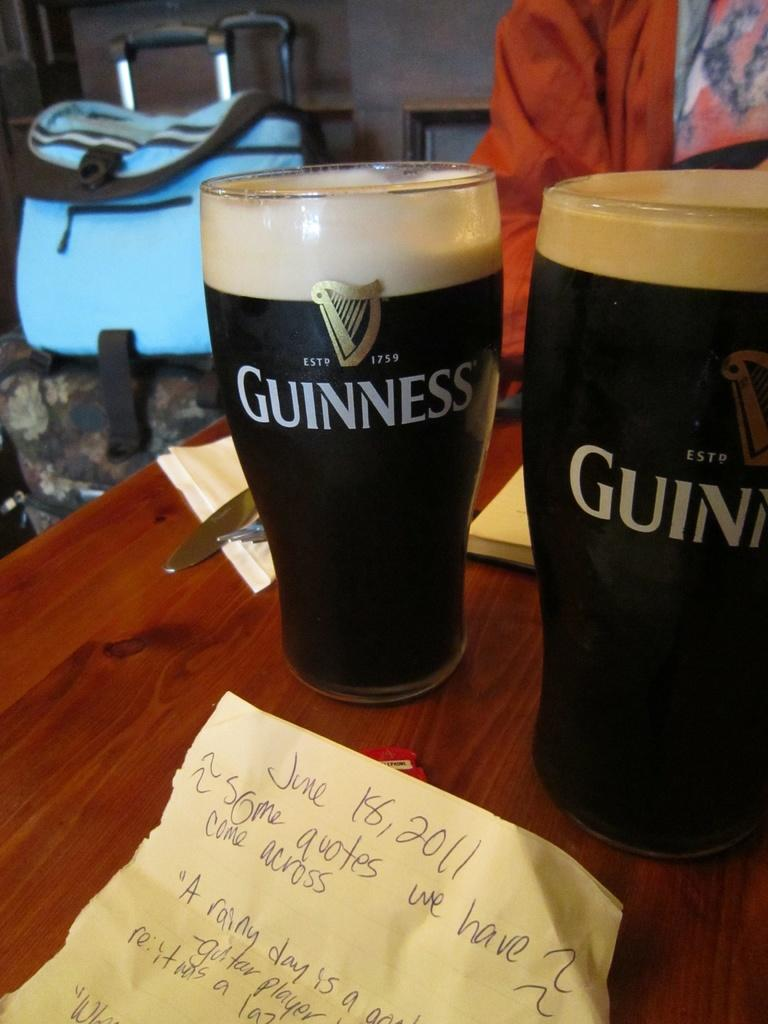How many glasses can be seen in the image? There are two glasses in the image. What else is present in the image besides the glasses? There are papers and other objects on a wooden surface in the image. Can you describe the background of the image? There is a person and a bag in the background of the image. What type of flame can be seen on the roof in the image? There is no flame or roof present in the image. 